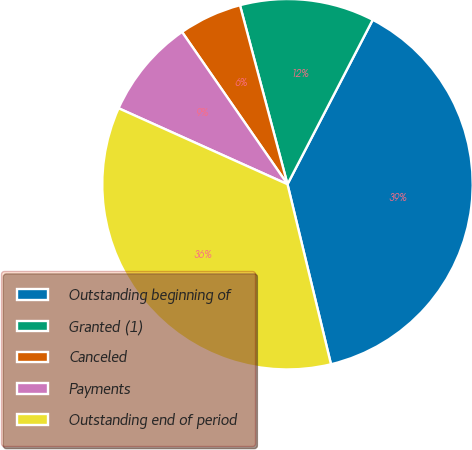Convert chart to OTSL. <chart><loc_0><loc_0><loc_500><loc_500><pie_chart><fcel>Outstanding beginning of<fcel>Granted (1)<fcel>Canceled<fcel>Payments<fcel>Outstanding end of period<nl><fcel>38.61%<fcel>11.74%<fcel>5.51%<fcel>8.63%<fcel>35.5%<nl></chart> 